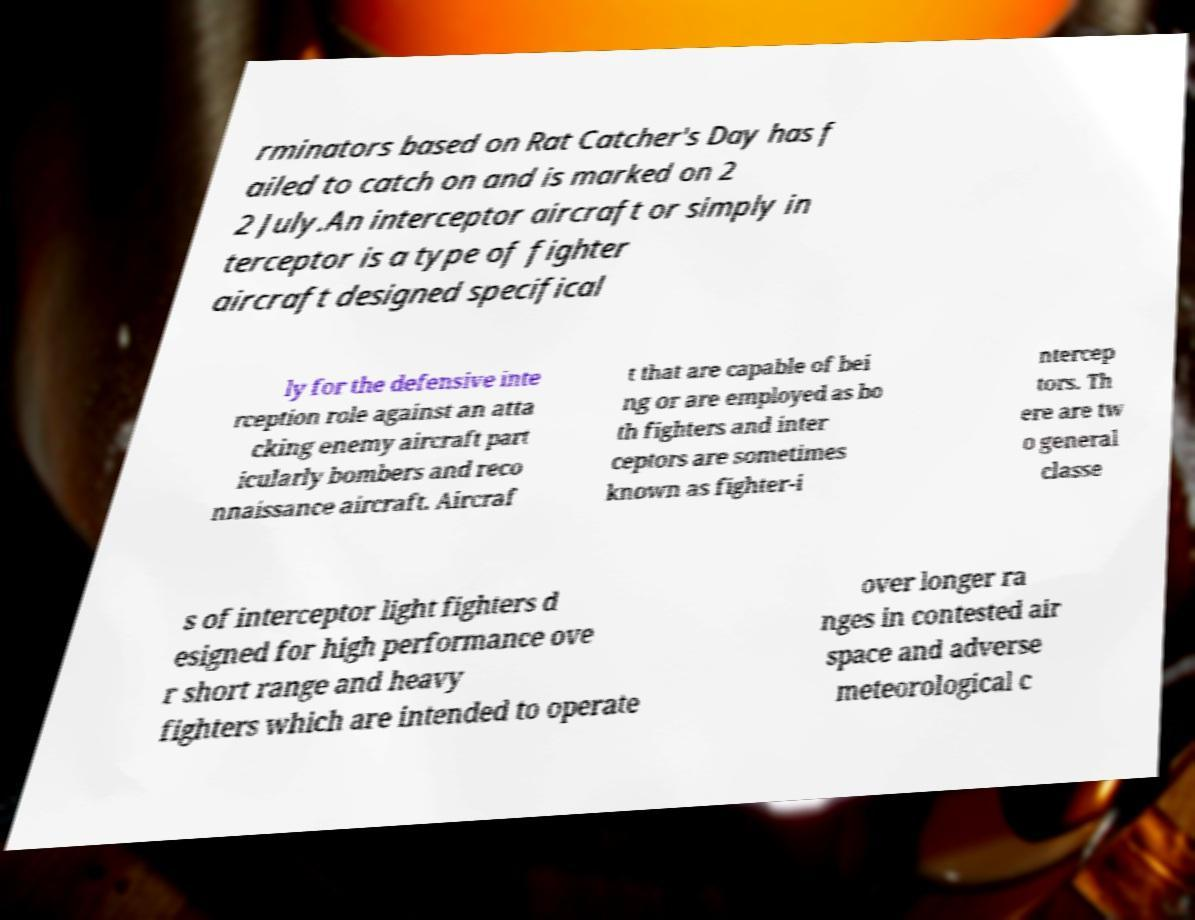Please identify and transcribe the text found in this image. rminators based on Rat Catcher's Day has f ailed to catch on and is marked on 2 2 July.An interceptor aircraft or simply in terceptor is a type of fighter aircraft designed specifical ly for the defensive inte rception role against an atta cking enemy aircraft part icularly bombers and reco nnaissance aircraft. Aircraf t that are capable of bei ng or are employed as bo th fighters and inter ceptors are sometimes known as fighter-i ntercep tors. Th ere are tw o general classe s of interceptor light fighters d esigned for high performance ove r short range and heavy fighters which are intended to operate over longer ra nges in contested air space and adverse meteorological c 